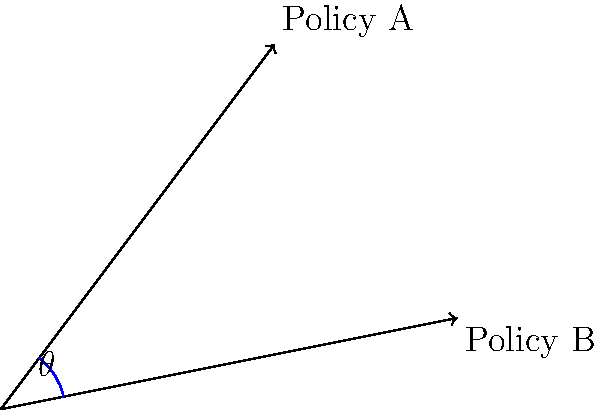Two conflicting policy directions, Policy A and Policy B, are represented by vectors in a 2D plane. Policy A is represented by the vector (3, 4), and Policy B is represented by the vector (5, 1). What is the angle $\theta$ between these two policy directions, rounded to the nearest degree? To find the angle between two vectors, we can use the dot product formula:

1) The dot product formula: $\cos \theta = \frac{\mathbf{a} \cdot \mathbf{b}}{|\mathbf{a}||\mathbf{b}|}$

2) Calculate the dot product $\mathbf{a} \cdot \mathbf{b}$:
   $\mathbf{a} \cdot \mathbf{b} = (3)(5) + (4)(1) = 15 + 4 = 19$

3) Calculate the magnitudes:
   $|\mathbf{a}| = \sqrt{3^2 + 4^2} = \sqrt{25} = 5$
   $|\mathbf{b}| = \sqrt{5^2 + 1^2} = \sqrt{26}$

4) Substitute into the formula:
   $\cos \theta = \frac{19}{5\sqrt{26}}$

5) Take the inverse cosine (arccos) of both sides:
   $\theta = \arccos(\frac{19}{5\sqrt{26}})$

6) Calculate and round to the nearest degree:
   $\theta \approx 22.6°$, which rounds to 23°
Answer: 23° 